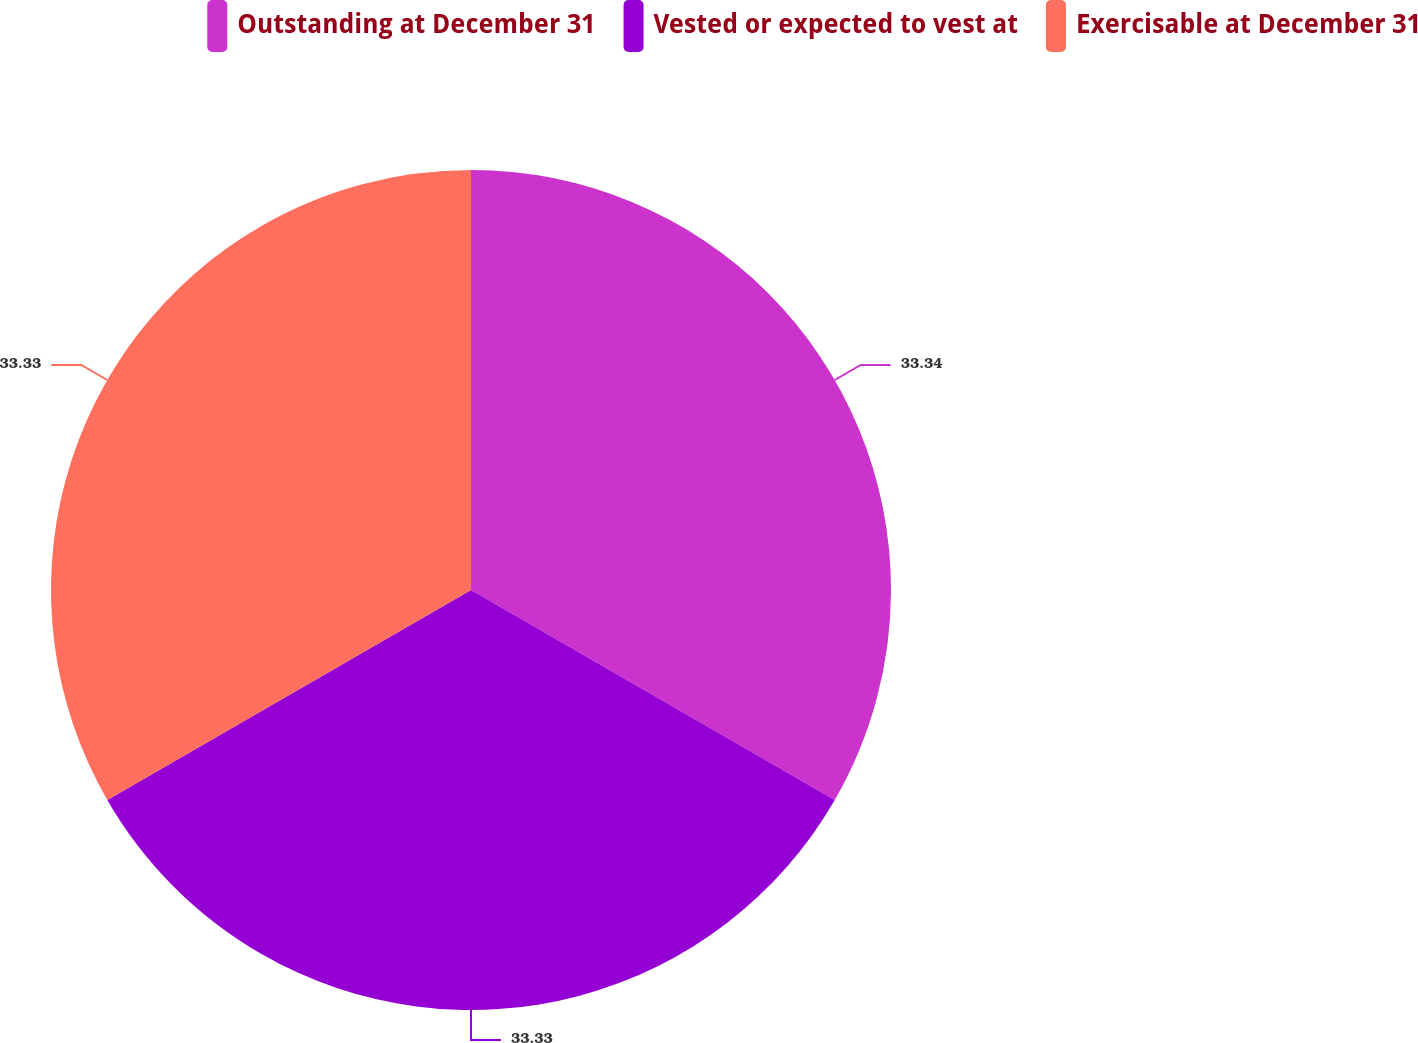Convert chart to OTSL. <chart><loc_0><loc_0><loc_500><loc_500><pie_chart><fcel>Outstanding at December 31<fcel>Vested or expected to vest at<fcel>Exercisable at December 31<nl><fcel>33.33%<fcel>33.33%<fcel>33.33%<nl></chart> 